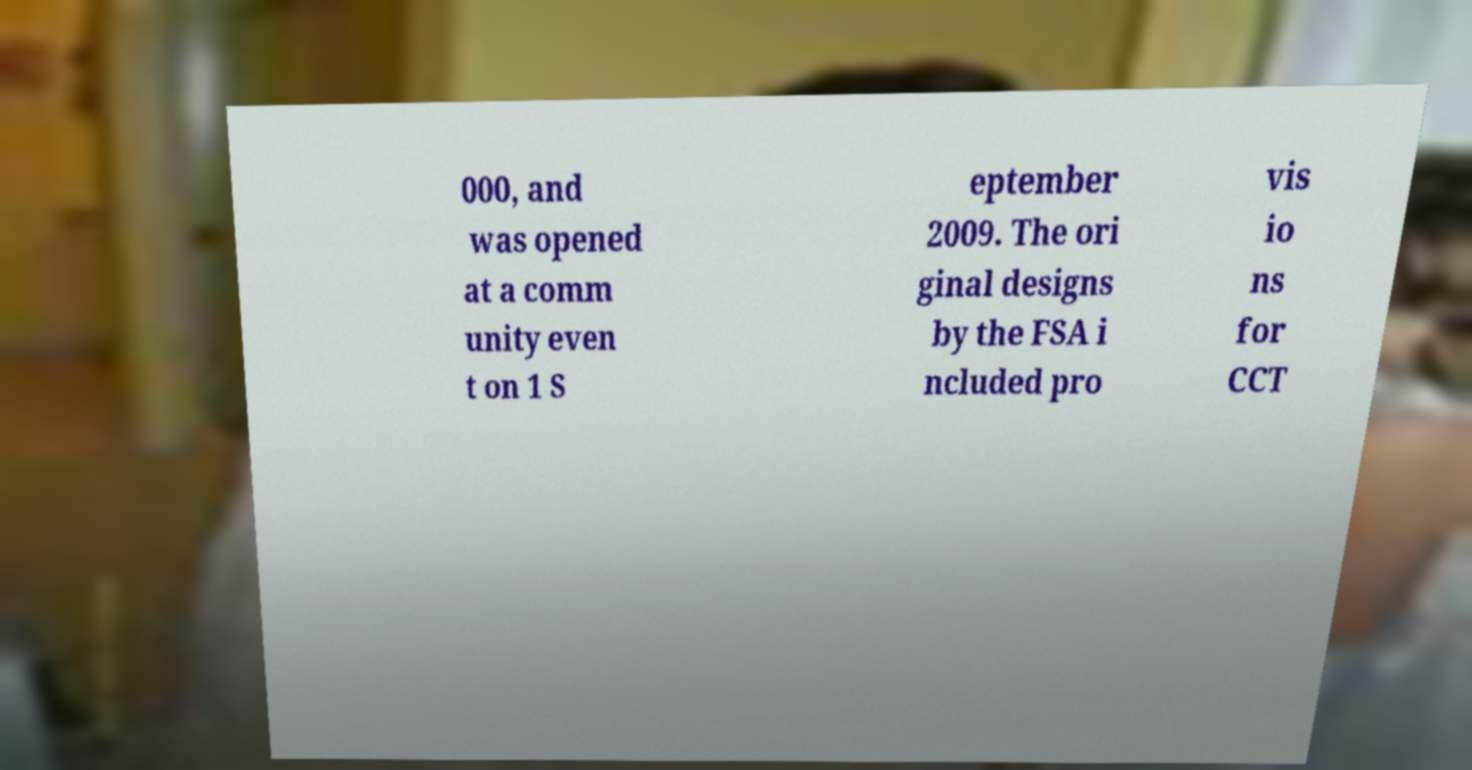Could you extract and type out the text from this image? 000, and was opened at a comm unity even t on 1 S eptember 2009. The ori ginal designs by the FSA i ncluded pro vis io ns for CCT 